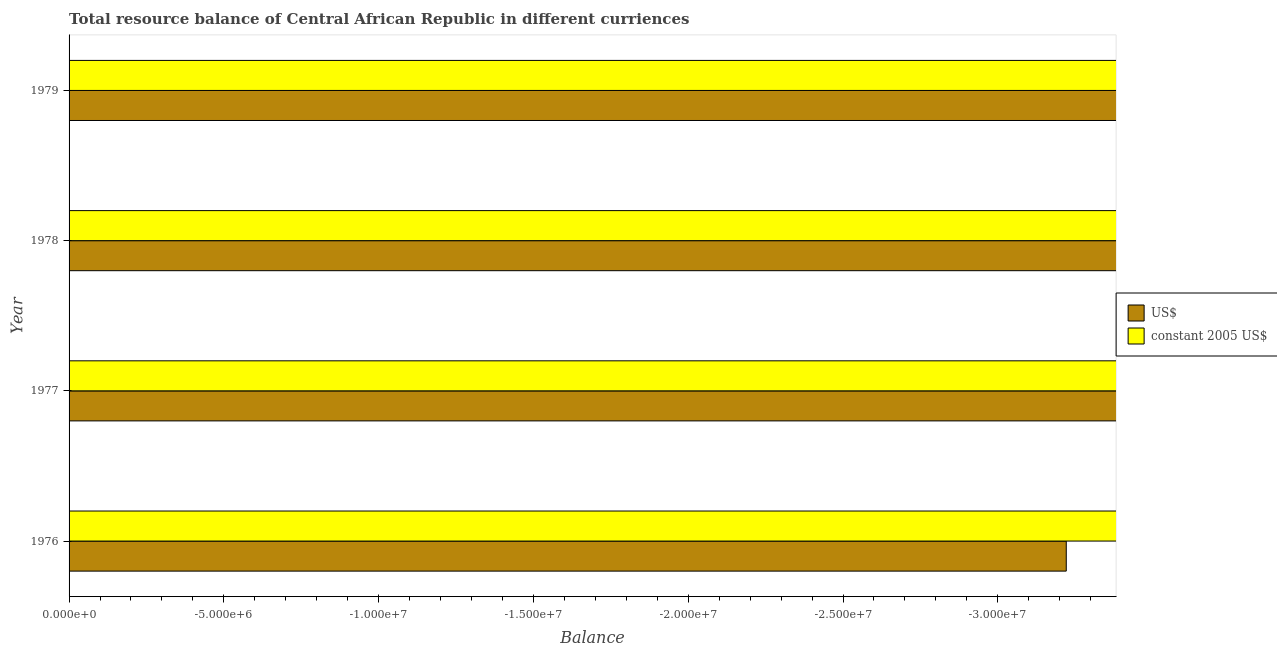How many bars are there on the 3rd tick from the bottom?
Your response must be concise. 0. What is the label of the 1st group of bars from the top?
Your answer should be compact. 1979. What is the resource balance in constant us$ in 1978?
Your answer should be compact. 0. What is the difference between the resource balance in constant us$ in 1977 and the resource balance in us$ in 1978?
Offer a very short reply. 0. What is the average resource balance in us$ per year?
Make the answer very short. 0. In how many years, is the resource balance in us$ greater than the average resource balance in us$ taken over all years?
Provide a short and direct response. 0. How many bars are there?
Your answer should be compact. 0. Are all the bars in the graph horizontal?
Make the answer very short. Yes. How many years are there in the graph?
Offer a terse response. 4. Are the values on the major ticks of X-axis written in scientific E-notation?
Give a very brief answer. Yes. Does the graph contain any zero values?
Keep it short and to the point. Yes. Where does the legend appear in the graph?
Offer a very short reply. Center right. How many legend labels are there?
Your answer should be compact. 2. How are the legend labels stacked?
Your answer should be compact. Vertical. What is the title of the graph?
Your answer should be very brief. Total resource balance of Central African Republic in different curriences. Does "Attending school" appear as one of the legend labels in the graph?
Provide a short and direct response. No. What is the label or title of the X-axis?
Offer a very short reply. Balance. What is the Balance of US$ in 1976?
Keep it short and to the point. 0. What is the Balance in US$ in 1977?
Provide a short and direct response. 0. What is the Balance of constant 2005 US$ in 1977?
Ensure brevity in your answer.  0. What is the Balance in constant 2005 US$ in 1978?
Provide a short and direct response. 0. What is the Balance in US$ in 1979?
Your answer should be compact. 0. What is the Balance in constant 2005 US$ in 1979?
Ensure brevity in your answer.  0. What is the total Balance of US$ in the graph?
Your response must be concise. 0. What is the average Balance of US$ per year?
Provide a short and direct response. 0. 